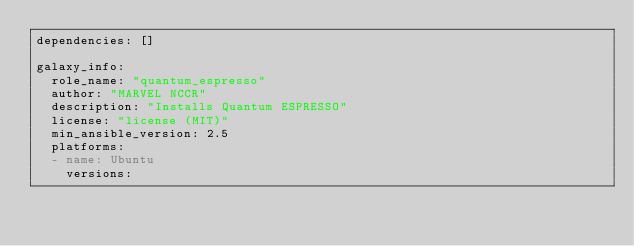Convert code to text. <code><loc_0><loc_0><loc_500><loc_500><_YAML_>dependencies: []

galaxy_info:
  role_name: "quantum_espresso"
  author: "MARVEL NCCR"
  description: "Installs Quantum ESPRESSO"
  license: "license (MIT)"
  min_ansible_version: 2.5
  platforms:
  - name: Ubuntu
    versions:</code> 